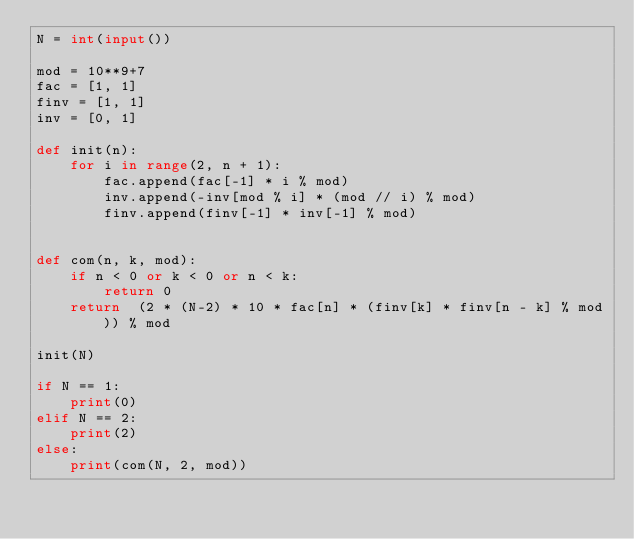Convert code to text. <code><loc_0><loc_0><loc_500><loc_500><_Python_>N = int(input())

mod = 10**9+7
fac = [1, 1]
finv = [1, 1]
inv = [0, 1]

def init(n):
    for i in range(2, n + 1):
        fac.append(fac[-1] * i % mod)
        inv.append(-inv[mod % i] * (mod // i) % mod)
        finv.append(finv[-1] * inv[-1] % mod)


def com(n, k, mod):
    if n < 0 or k < 0 or n < k:
        return 0
    return  (2 * (N-2) * 10 * fac[n] * (finv[k] * finv[n - k] % mod)) % mod

init(N)

if N == 1:
    print(0)
elif N == 2:
    print(2)
else:
    print(com(N, 2, mod))</code> 